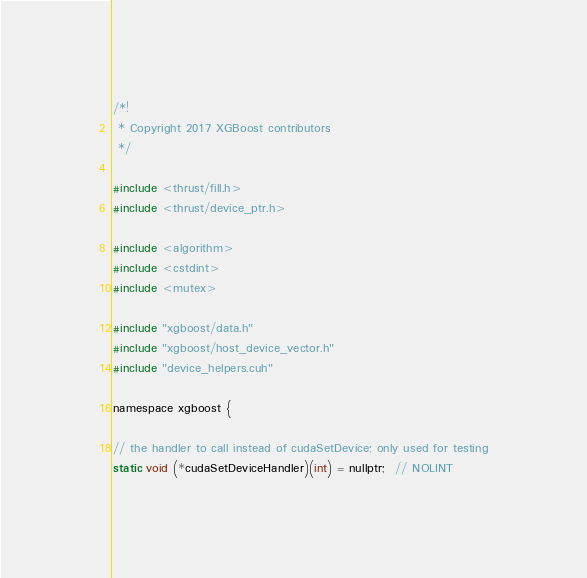Convert code to text. <code><loc_0><loc_0><loc_500><loc_500><_Cuda_>/*!
 * Copyright 2017 XGBoost contributors
 */

#include <thrust/fill.h>
#include <thrust/device_ptr.h>

#include <algorithm>
#include <cstdint>
#include <mutex>

#include "xgboost/data.h"
#include "xgboost/host_device_vector.h"
#include "device_helpers.cuh"

namespace xgboost {

// the handler to call instead of cudaSetDevice; only used for testing
static void (*cudaSetDeviceHandler)(int) = nullptr;  // NOLINT
</code> 